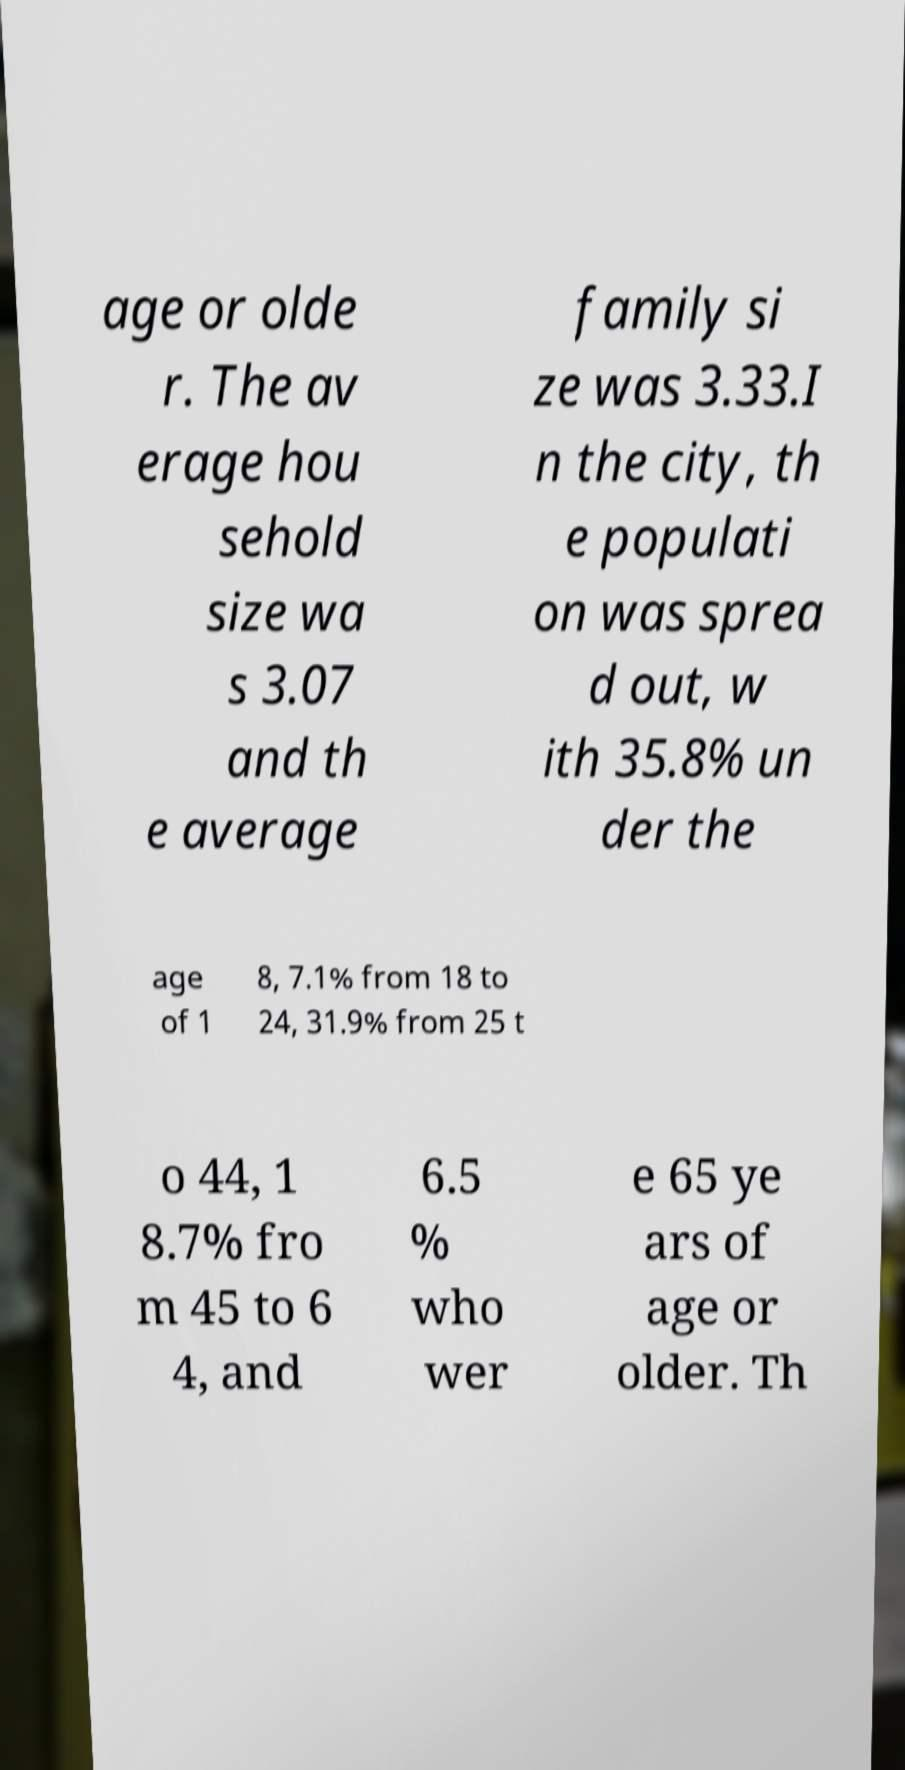For documentation purposes, I need the text within this image transcribed. Could you provide that? age or olde r. The av erage hou sehold size wa s 3.07 and th e average family si ze was 3.33.I n the city, th e populati on was sprea d out, w ith 35.8% un der the age of 1 8, 7.1% from 18 to 24, 31.9% from 25 t o 44, 1 8.7% fro m 45 to 6 4, and 6.5 % who wer e 65 ye ars of age or older. Th 